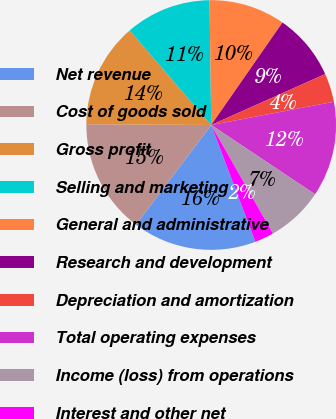Convert chart to OTSL. <chart><loc_0><loc_0><loc_500><loc_500><pie_chart><fcel>Net revenue<fcel>Cost of goods sold<fcel>Gross profit<fcel>Selling and marketing<fcel>General and administrative<fcel>Research and development<fcel>Depreciation and amortization<fcel>Total operating expenses<fcel>Income (loss) from operations<fcel>Interest and other net<nl><fcel>16.04%<fcel>14.81%<fcel>13.58%<fcel>11.11%<fcel>9.88%<fcel>8.64%<fcel>3.71%<fcel>12.34%<fcel>7.41%<fcel>2.48%<nl></chart> 